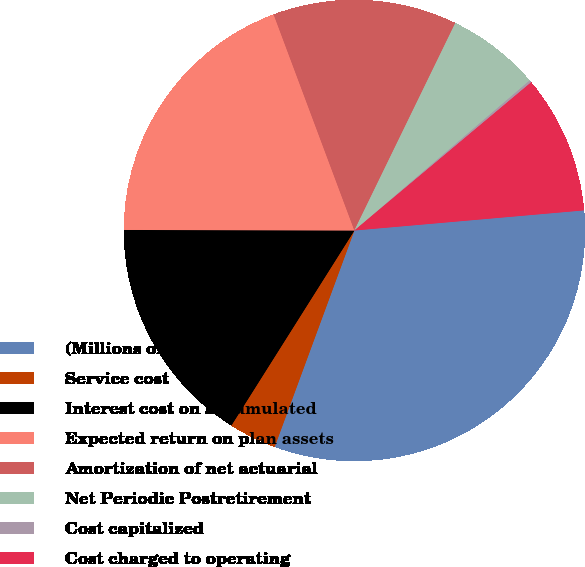Convert chart to OTSL. <chart><loc_0><loc_0><loc_500><loc_500><pie_chart><fcel>(Millions of Dollars)<fcel>Service cost<fcel>Interest cost on accumulated<fcel>Expected return on plan assets<fcel>Amortization of net actuarial<fcel>Net Periodic Postretirement<fcel>Cost capitalized<fcel>Cost charged to operating<nl><fcel>32.01%<fcel>3.34%<fcel>16.08%<fcel>19.27%<fcel>12.9%<fcel>6.53%<fcel>0.16%<fcel>9.71%<nl></chart> 